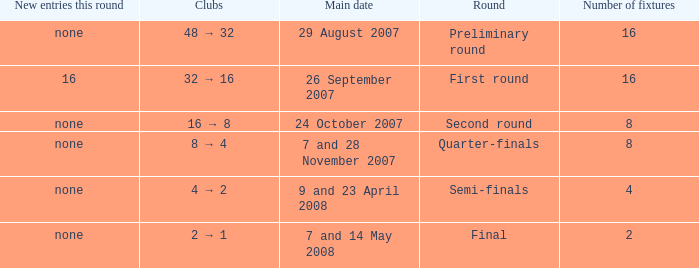What is the sum of Number of fixtures when the rounds shows quarter-finals? 8.0. 